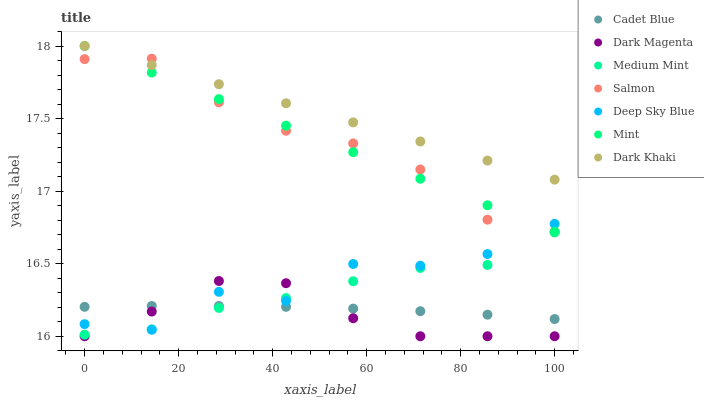Does Dark Magenta have the minimum area under the curve?
Answer yes or no. Yes. Does Dark Khaki have the maximum area under the curve?
Answer yes or no. Yes. Does Cadet Blue have the minimum area under the curve?
Answer yes or no. No. Does Cadet Blue have the maximum area under the curve?
Answer yes or no. No. Is Dark Khaki the smoothest?
Answer yes or no. Yes. Is Deep Sky Blue the roughest?
Answer yes or no. Yes. Is Cadet Blue the smoothest?
Answer yes or no. No. Is Cadet Blue the roughest?
Answer yes or no. No. Does Dark Magenta have the lowest value?
Answer yes or no. Yes. Does Cadet Blue have the lowest value?
Answer yes or no. No. Does Mint have the highest value?
Answer yes or no. Yes. Does Dark Magenta have the highest value?
Answer yes or no. No. Is Cadet Blue less than Salmon?
Answer yes or no. Yes. Is Mint greater than Cadet Blue?
Answer yes or no. Yes. Does Dark Magenta intersect Cadet Blue?
Answer yes or no. Yes. Is Dark Magenta less than Cadet Blue?
Answer yes or no. No. Is Dark Magenta greater than Cadet Blue?
Answer yes or no. No. Does Cadet Blue intersect Salmon?
Answer yes or no. No. 